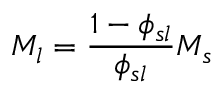Convert formula to latex. <formula><loc_0><loc_0><loc_500><loc_500>M _ { l } = { \frac { 1 - \phi _ { s l } } { \phi _ { s l } } } M _ { s }</formula> 